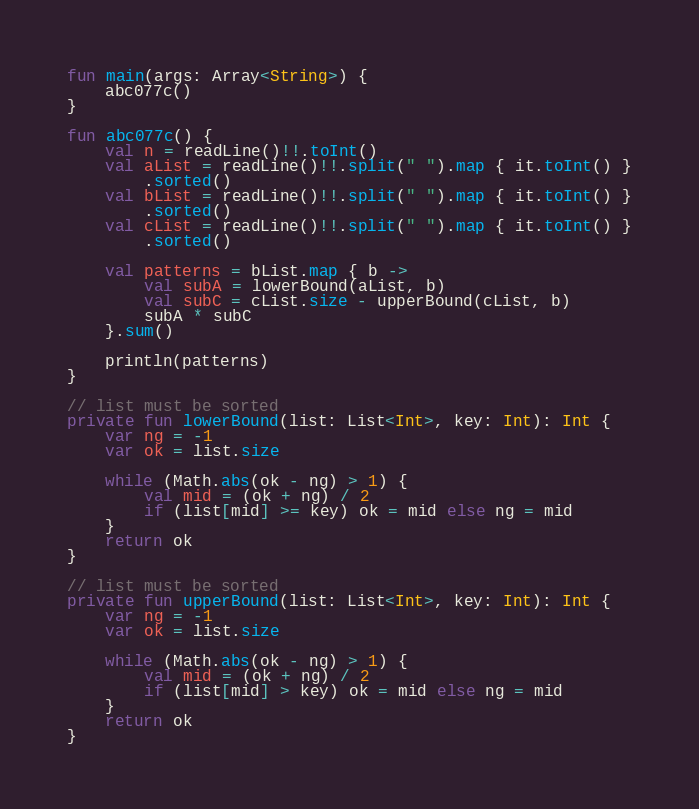<code> <loc_0><loc_0><loc_500><loc_500><_Kotlin_>fun main(args: Array<String>) {
    abc077c()
}

fun abc077c() {
    val n = readLine()!!.toInt()
    val aList = readLine()!!.split(" ").map { it.toInt() }
        .sorted()
    val bList = readLine()!!.split(" ").map { it.toInt() }
        .sorted()
    val cList = readLine()!!.split(" ").map { it.toInt() }
        .sorted()

    val patterns = bList.map { b ->
        val subA = lowerBound(aList, b)
        val subC = cList.size - upperBound(cList, b)
        subA * subC
    }.sum()

    println(patterns)
}

// list must be sorted
private fun lowerBound(list: List<Int>, key: Int): Int {
    var ng = -1
    var ok = list.size

    while (Math.abs(ok - ng) > 1) {
        val mid = (ok + ng) / 2
        if (list[mid] >= key) ok = mid else ng = mid
    }
    return ok
}

// list must be sorted
private fun upperBound(list: List<Int>, key: Int): Int {
    var ng = -1
    var ok = list.size

    while (Math.abs(ok - ng) > 1) {
        val mid = (ok + ng) / 2
        if (list[mid] > key) ok = mid else ng = mid
    }
    return ok
}
</code> 